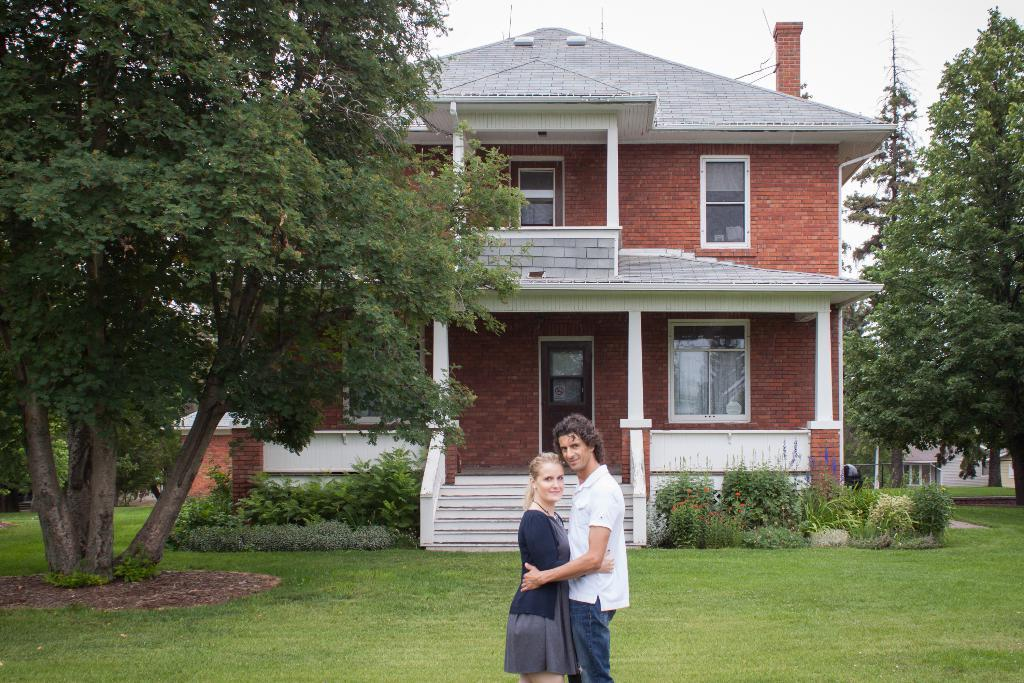How many people are in the image? There are two persons standing in the middle of the image. What are the people doing in the image? The persons are smiling. What type of natural environment is visible in the image? There is grass, plants, and trees visible in the image. What type of structure can be seen in the image? There is a building in the image. What is visible at the top of the image? The sky is visible at the top of the image. What type of wren can be seen perched on the nail in the image? There is no wren or nail present in the image. What type of oatmeal is being served in the image? There is no oatmeal present in the image. 